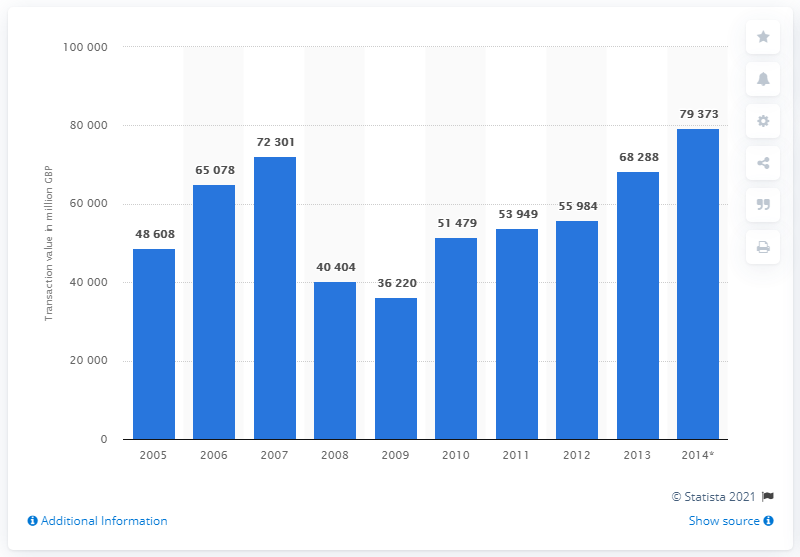Point out several critical features in this image. In 2013, there were 68,288 residential property transactions taking place on the London market. In 2014, the value of residential property transactions on the London real estate market was 79,373. 